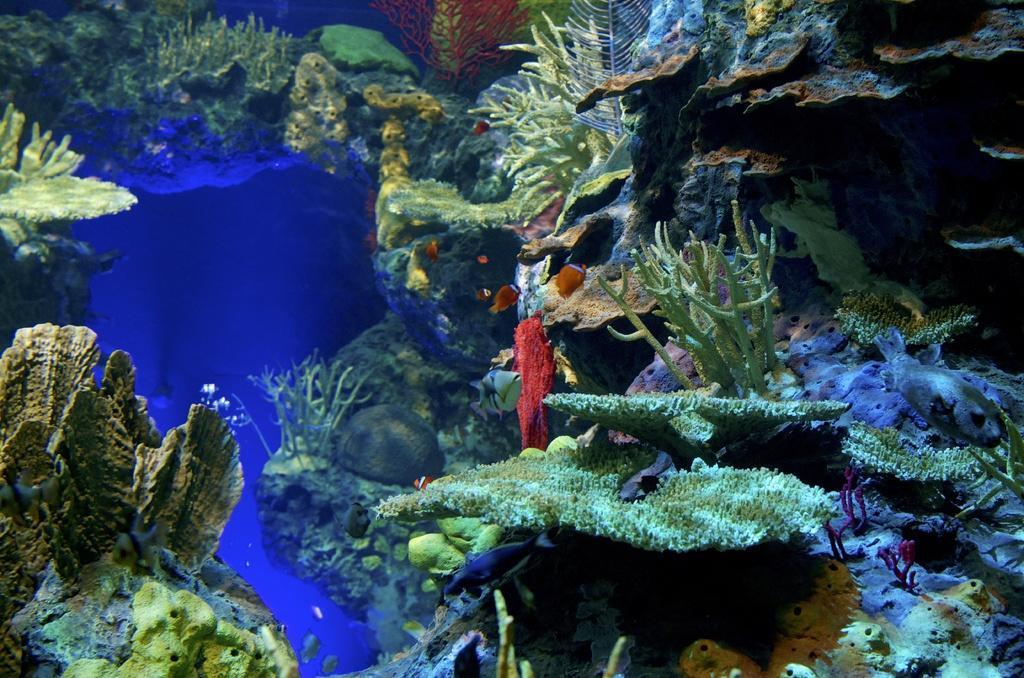Can you describe this image briefly? This is an underwater environment. In this picture we can see corals. We can see fishes. 